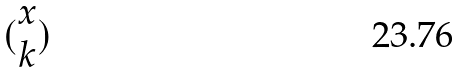<formula> <loc_0><loc_0><loc_500><loc_500>( \begin{matrix} x \\ k \end{matrix} )</formula> 